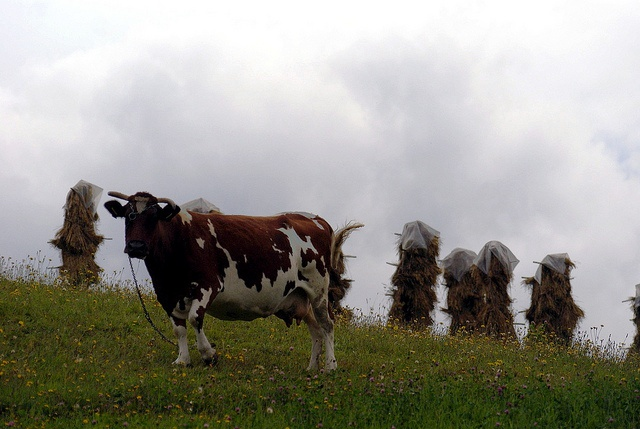Describe the objects in this image and their specific colors. I can see a cow in white, black, gray, and maroon tones in this image. 